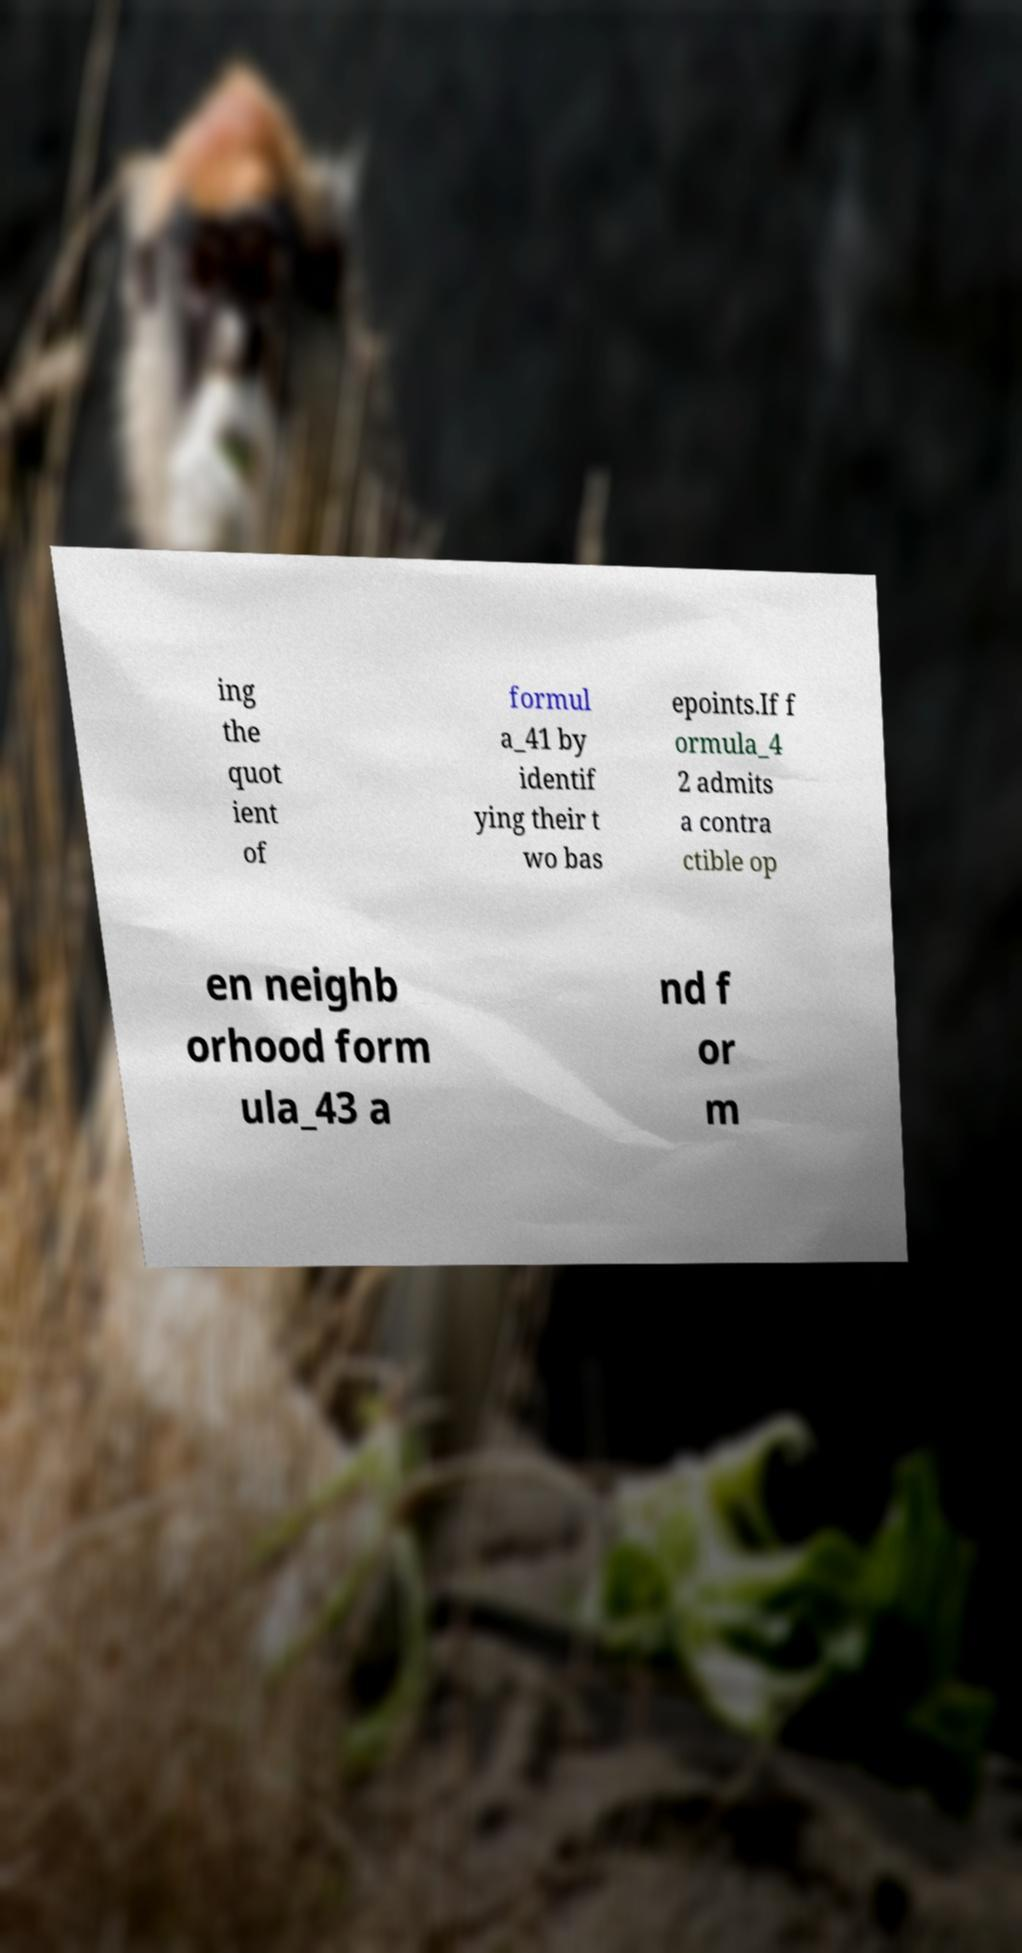There's text embedded in this image that I need extracted. Can you transcribe it verbatim? ing the quot ient of formul a_41 by identif ying their t wo bas epoints.If f ormula_4 2 admits a contra ctible op en neighb orhood form ula_43 a nd f or m 